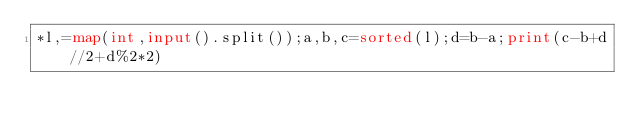Convert code to text. <code><loc_0><loc_0><loc_500><loc_500><_Python_>*l,=map(int,input().split());a,b,c=sorted(l);d=b-a;print(c-b+d//2+d%2*2)</code> 